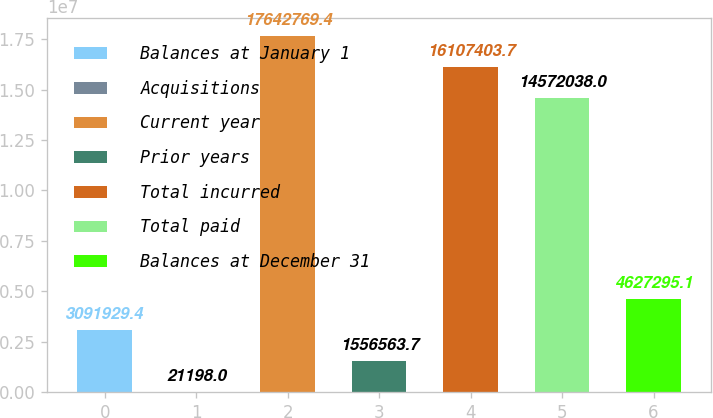Convert chart. <chart><loc_0><loc_0><loc_500><loc_500><bar_chart><fcel>Balances at January 1<fcel>Acquisitions<fcel>Current year<fcel>Prior years<fcel>Total incurred<fcel>Total paid<fcel>Balances at December 31<nl><fcel>3.09193e+06<fcel>21198<fcel>1.76428e+07<fcel>1.55656e+06<fcel>1.61074e+07<fcel>1.4572e+07<fcel>4.6273e+06<nl></chart> 